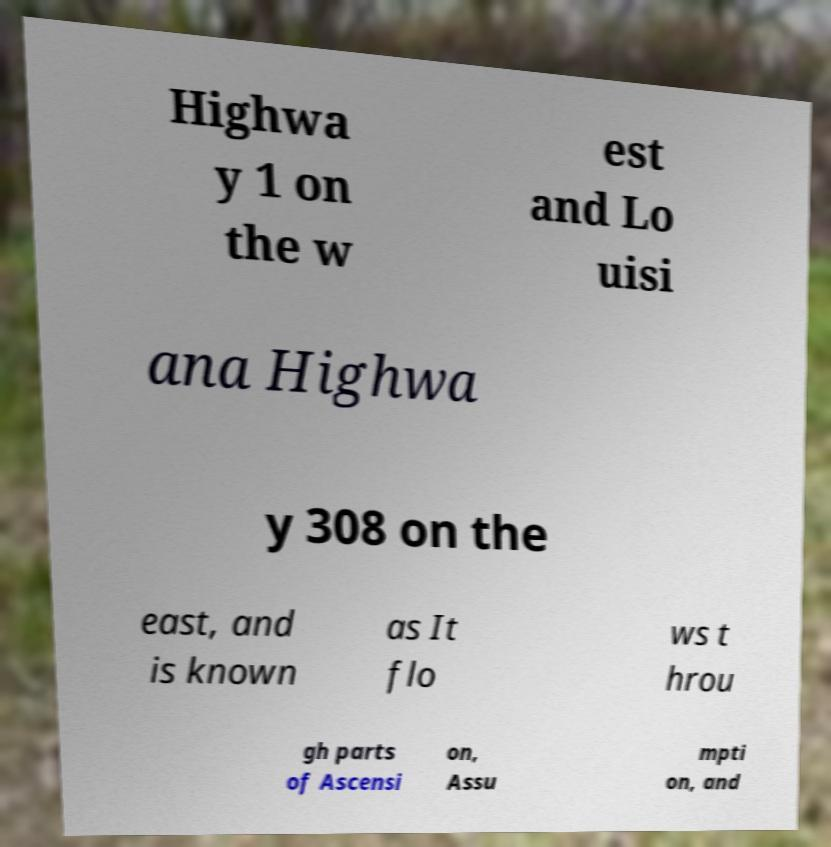Can you accurately transcribe the text from the provided image for me? Highwa y 1 on the w est and Lo uisi ana Highwa y 308 on the east, and is known as It flo ws t hrou gh parts of Ascensi on, Assu mpti on, and 